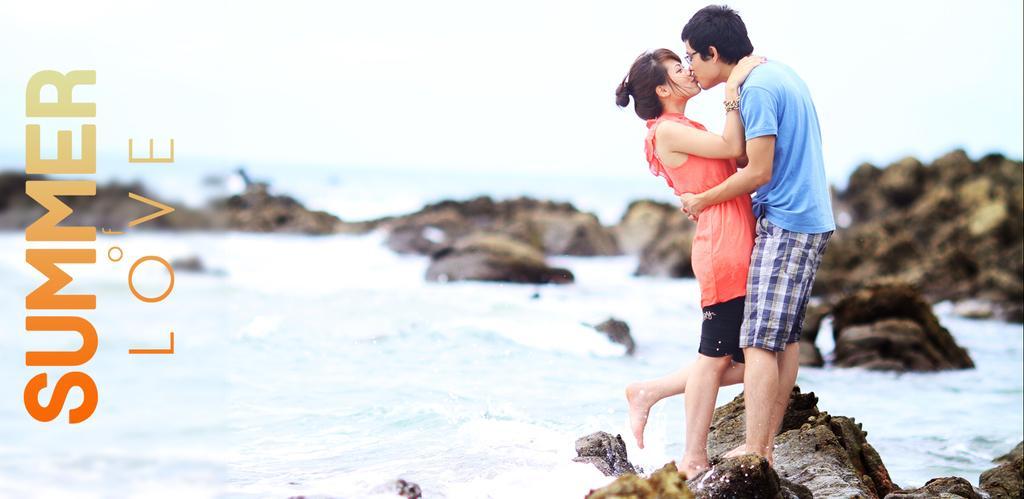In one or two sentences, can you explain what this image depicts? In this image, we can see a couple standing on the rock and they are kissing, we can see some rocks in the water. 